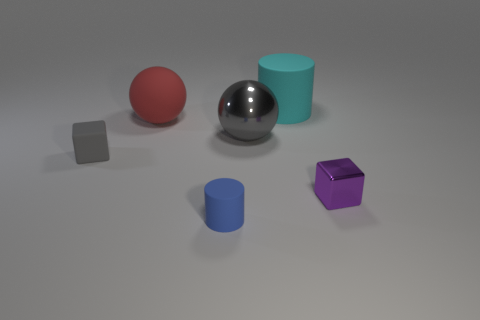Are any red cylinders visible?
Provide a short and direct response. No. What color is the small object that is left of the cylinder that is in front of the rubber block left of the shiny ball?
Keep it short and to the point. Gray. There is a small cube to the right of the blue rubber cylinder; are there any small purple shiny things in front of it?
Offer a terse response. No. Do the rubber object that is on the right side of the small blue cylinder and the large sphere that is on the left side of the blue thing have the same color?
Keep it short and to the point. No. How many spheres have the same size as the blue rubber cylinder?
Give a very brief answer. 0. Do the cylinder in front of the purple metal block and the small metal cube have the same size?
Keep it short and to the point. Yes. The blue rubber object is what shape?
Offer a very short reply. Cylinder. There is a rubber object that is the same color as the metal sphere; what is its size?
Your answer should be very brief. Small. Do the tiny cube that is in front of the tiny gray block and the large cyan thing have the same material?
Provide a succinct answer. No. Is there a cylinder that has the same color as the tiny metal thing?
Provide a short and direct response. No. 